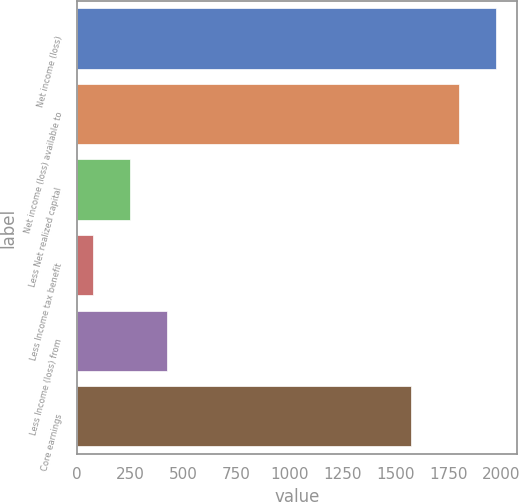Convert chart to OTSL. <chart><loc_0><loc_0><loc_500><loc_500><bar_chart><fcel>Net income (loss)<fcel>Net income (loss) available to<fcel>Less Net realized capital<fcel>Less Income tax benefit<fcel>Less Income (loss) from<fcel>Core earnings<nl><fcel>1974.2<fcel>1801<fcel>248.2<fcel>75<fcel>421.4<fcel>1575<nl></chart> 